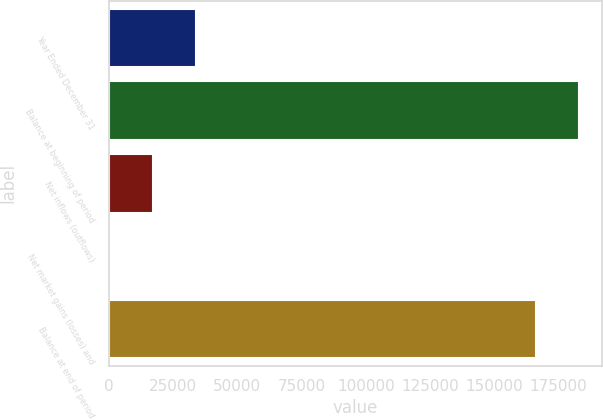<chart> <loc_0><loc_0><loc_500><loc_500><bar_chart><fcel>Year Ended December 31<fcel>Balance at beginning of period<fcel>Net inflows (outflows)<fcel>Net market gains (losses) and<fcel>Balance at end of period<nl><fcel>33730.6<fcel>182920<fcel>16958.3<fcel>186<fcel>166148<nl></chart> 